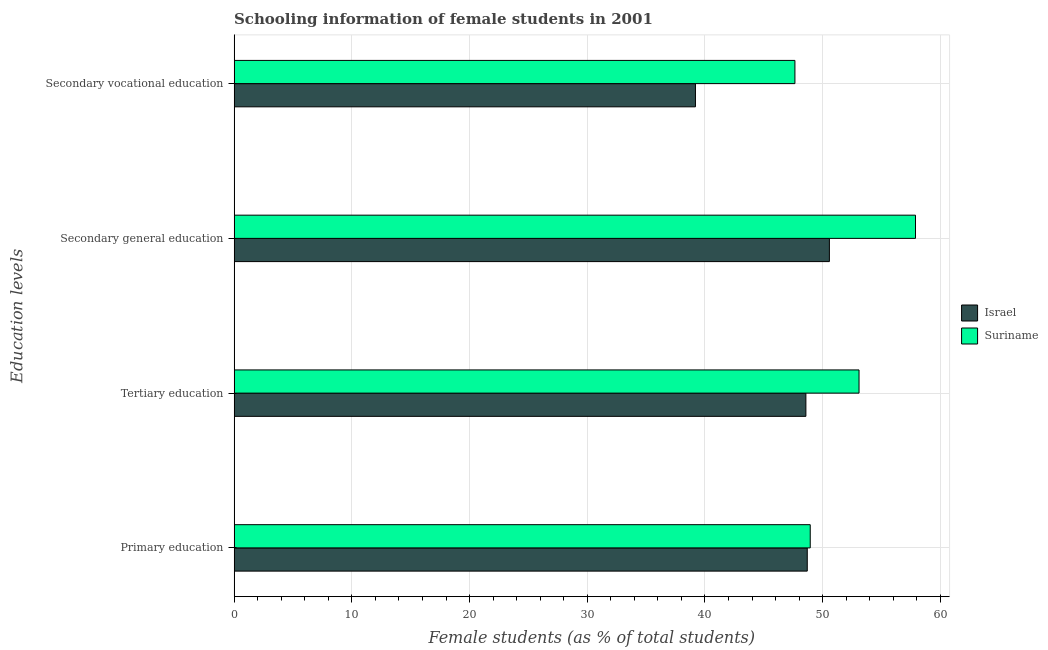How many different coloured bars are there?
Provide a succinct answer. 2. Are the number of bars per tick equal to the number of legend labels?
Your answer should be very brief. Yes. What is the label of the 2nd group of bars from the top?
Provide a short and direct response. Secondary general education. What is the percentage of female students in secondary education in Suriname?
Your answer should be compact. 57.89. Across all countries, what is the maximum percentage of female students in secondary vocational education?
Provide a short and direct response. 47.64. Across all countries, what is the minimum percentage of female students in tertiary education?
Provide a short and direct response. 48.58. In which country was the percentage of female students in secondary vocational education maximum?
Provide a short and direct response. Suriname. What is the total percentage of female students in primary education in the graph?
Offer a very short reply. 97.64. What is the difference between the percentage of female students in tertiary education in Suriname and that in Israel?
Offer a very short reply. 4.51. What is the difference between the percentage of female students in tertiary education in Suriname and the percentage of female students in secondary education in Israel?
Your response must be concise. 2.52. What is the average percentage of female students in tertiary education per country?
Offer a terse response. 50.83. What is the difference between the percentage of female students in primary education and percentage of female students in secondary education in Suriname?
Offer a very short reply. -8.94. What is the ratio of the percentage of female students in secondary education in Israel to that in Suriname?
Ensure brevity in your answer.  0.87. What is the difference between the highest and the second highest percentage of female students in primary education?
Give a very brief answer. 0.25. What is the difference between the highest and the lowest percentage of female students in secondary education?
Your answer should be very brief. 7.32. Is it the case that in every country, the sum of the percentage of female students in primary education and percentage of female students in tertiary education is greater than the percentage of female students in secondary education?
Your response must be concise. Yes. How many countries are there in the graph?
Keep it short and to the point. 2. Are the values on the major ticks of X-axis written in scientific E-notation?
Make the answer very short. No. Where does the legend appear in the graph?
Keep it short and to the point. Center right. How many legend labels are there?
Offer a terse response. 2. What is the title of the graph?
Offer a very short reply. Schooling information of female students in 2001. What is the label or title of the X-axis?
Provide a short and direct response. Female students (as % of total students). What is the label or title of the Y-axis?
Your answer should be compact. Education levels. What is the Female students (as % of total students) of Israel in Primary education?
Your answer should be very brief. 48.69. What is the Female students (as % of total students) in Suriname in Primary education?
Make the answer very short. 48.95. What is the Female students (as % of total students) of Israel in Tertiary education?
Keep it short and to the point. 48.58. What is the Female students (as % of total students) of Suriname in Tertiary education?
Ensure brevity in your answer.  53.09. What is the Female students (as % of total students) of Israel in Secondary general education?
Your response must be concise. 50.57. What is the Female students (as % of total students) in Suriname in Secondary general education?
Give a very brief answer. 57.89. What is the Female students (as % of total students) of Israel in Secondary vocational education?
Keep it short and to the point. 39.19. What is the Female students (as % of total students) of Suriname in Secondary vocational education?
Offer a terse response. 47.64. Across all Education levels, what is the maximum Female students (as % of total students) in Israel?
Give a very brief answer. 50.57. Across all Education levels, what is the maximum Female students (as % of total students) in Suriname?
Give a very brief answer. 57.89. Across all Education levels, what is the minimum Female students (as % of total students) in Israel?
Give a very brief answer. 39.19. Across all Education levels, what is the minimum Female students (as % of total students) of Suriname?
Provide a succinct answer. 47.64. What is the total Female students (as % of total students) of Israel in the graph?
Make the answer very short. 187.03. What is the total Female students (as % of total students) of Suriname in the graph?
Ensure brevity in your answer.  207.57. What is the difference between the Female students (as % of total students) of Israel in Primary education and that in Tertiary education?
Offer a terse response. 0.12. What is the difference between the Female students (as % of total students) of Suriname in Primary education and that in Tertiary education?
Provide a short and direct response. -4.14. What is the difference between the Female students (as % of total students) in Israel in Primary education and that in Secondary general education?
Keep it short and to the point. -1.88. What is the difference between the Female students (as % of total students) of Suriname in Primary education and that in Secondary general education?
Provide a short and direct response. -8.94. What is the difference between the Female students (as % of total students) in Israel in Primary education and that in Secondary vocational education?
Your response must be concise. 9.5. What is the difference between the Female students (as % of total students) in Suriname in Primary education and that in Secondary vocational education?
Give a very brief answer. 1.3. What is the difference between the Female students (as % of total students) in Israel in Tertiary education and that in Secondary general education?
Give a very brief answer. -2. What is the difference between the Female students (as % of total students) of Suriname in Tertiary education and that in Secondary general education?
Offer a very short reply. -4.8. What is the difference between the Female students (as % of total students) of Israel in Tertiary education and that in Secondary vocational education?
Offer a very short reply. 9.38. What is the difference between the Female students (as % of total students) of Suriname in Tertiary education and that in Secondary vocational education?
Provide a succinct answer. 5.45. What is the difference between the Female students (as % of total students) in Israel in Secondary general education and that in Secondary vocational education?
Provide a short and direct response. 11.38. What is the difference between the Female students (as % of total students) of Suriname in Secondary general education and that in Secondary vocational education?
Give a very brief answer. 10.24. What is the difference between the Female students (as % of total students) of Israel in Primary education and the Female students (as % of total students) of Suriname in Tertiary education?
Ensure brevity in your answer.  -4.4. What is the difference between the Female students (as % of total students) of Israel in Primary education and the Female students (as % of total students) of Suriname in Secondary general education?
Keep it short and to the point. -9.2. What is the difference between the Female students (as % of total students) in Israel in Primary education and the Female students (as % of total students) in Suriname in Secondary vocational education?
Keep it short and to the point. 1.05. What is the difference between the Female students (as % of total students) in Israel in Tertiary education and the Female students (as % of total students) in Suriname in Secondary general education?
Make the answer very short. -9.31. What is the difference between the Female students (as % of total students) of Israel in Tertiary education and the Female students (as % of total students) of Suriname in Secondary vocational education?
Your answer should be compact. 0.93. What is the difference between the Female students (as % of total students) of Israel in Secondary general education and the Female students (as % of total students) of Suriname in Secondary vocational education?
Your answer should be compact. 2.93. What is the average Female students (as % of total students) of Israel per Education levels?
Offer a terse response. 46.76. What is the average Female students (as % of total students) of Suriname per Education levels?
Offer a terse response. 51.89. What is the difference between the Female students (as % of total students) in Israel and Female students (as % of total students) in Suriname in Primary education?
Make the answer very short. -0.25. What is the difference between the Female students (as % of total students) in Israel and Female students (as % of total students) in Suriname in Tertiary education?
Your answer should be very brief. -4.51. What is the difference between the Female students (as % of total students) in Israel and Female students (as % of total students) in Suriname in Secondary general education?
Offer a very short reply. -7.32. What is the difference between the Female students (as % of total students) of Israel and Female students (as % of total students) of Suriname in Secondary vocational education?
Provide a short and direct response. -8.45. What is the ratio of the Female students (as % of total students) of Suriname in Primary education to that in Tertiary education?
Offer a terse response. 0.92. What is the ratio of the Female students (as % of total students) in Israel in Primary education to that in Secondary general education?
Your response must be concise. 0.96. What is the ratio of the Female students (as % of total students) of Suriname in Primary education to that in Secondary general education?
Your response must be concise. 0.85. What is the ratio of the Female students (as % of total students) in Israel in Primary education to that in Secondary vocational education?
Make the answer very short. 1.24. What is the ratio of the Female students (as % of total students) in Suriname in Primary education to that in Secondary vocational education?
Offer a very short reply. 1.03. What is the ratio of the Female students (as % of total students) in Israel in Tertiary education to that in Secondary general education?
Ensure brevity in your answer.  0.96. What is the ratio of the Female students (as % of total students) of Suriname in Tertiary education to that in Secondary general education?
Your answer should be compact. 0.92. What is the ratio of the Female students (as % of total students) of Israel in Tertiary education to that in Secondary vocational education?
Ensure brevity in your answer.  1.24. What is the ratio of the Female students (as % of total students) in Suriname in Tertiary education to that in Secondary vocational education?
Provide a short and direct response. 1.11. What is the ratio of the Female students (as % of total students) of Israel in Secondary general education to that in Secondary vocational education?
Offer a very short reply. 1.29. What is the ratio of the Female students (as % of total students) in Suriname in Secondary general education to that in Secondary vocational education?
Offer a terse response. 1.22. What is the difference between the highest and the second highest Female students (as % of total students) in Israel?
Your answer should be very brief. 1.88. What is the difference between the highest and the second highest Female students (as % of total students) in Suriname?
Offer a terse response. 4.8. What is the difference between the highest and the lowest Female students (as % of total students) of Israel?
Ensure brevity in your answer.  11.38. What is the difference between the highest and the lowest Female students (as % of total students) in Suriname?
Your answer should be compact. 10.24. 